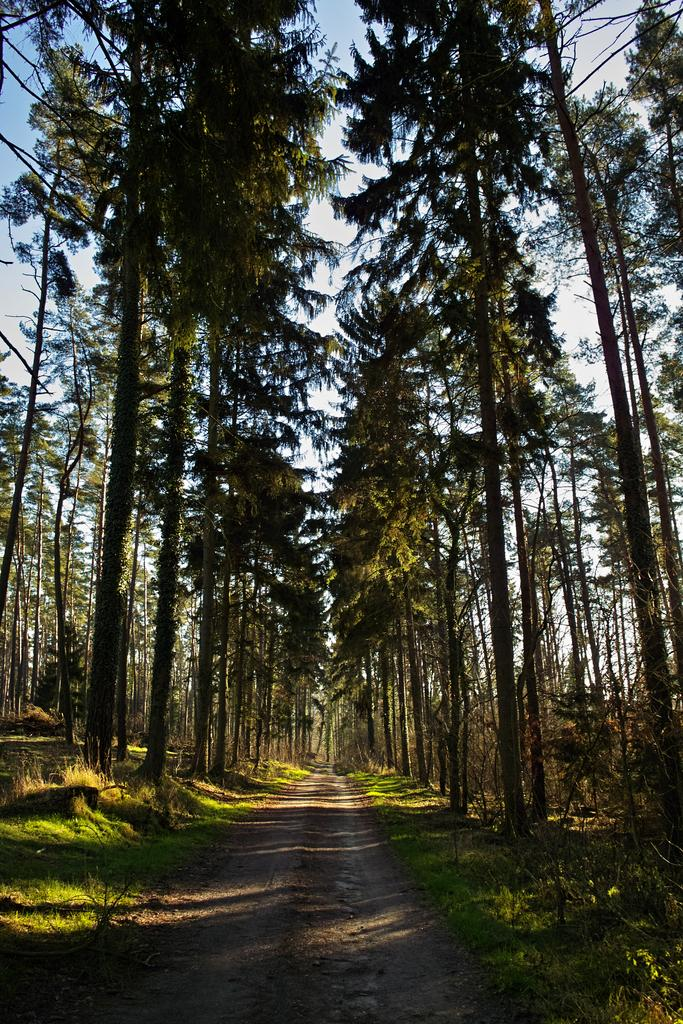What is the main feature of the image? There is a road in the image. What can be seen on both sides of the road? Trees and plants are present on both sides of the road. What is the ground covered with on both sides of the road? Grass is present on the ground on both sides of the road. What is visible in the background of the image? The sky is blue in the background of the image. Can you see a beggar asking for money on the side of the road in the image? There is no beggar present in the image. What type of cake is being sold by a vendor on the side of the road in the image? There is no cake or vendor present in the image. 